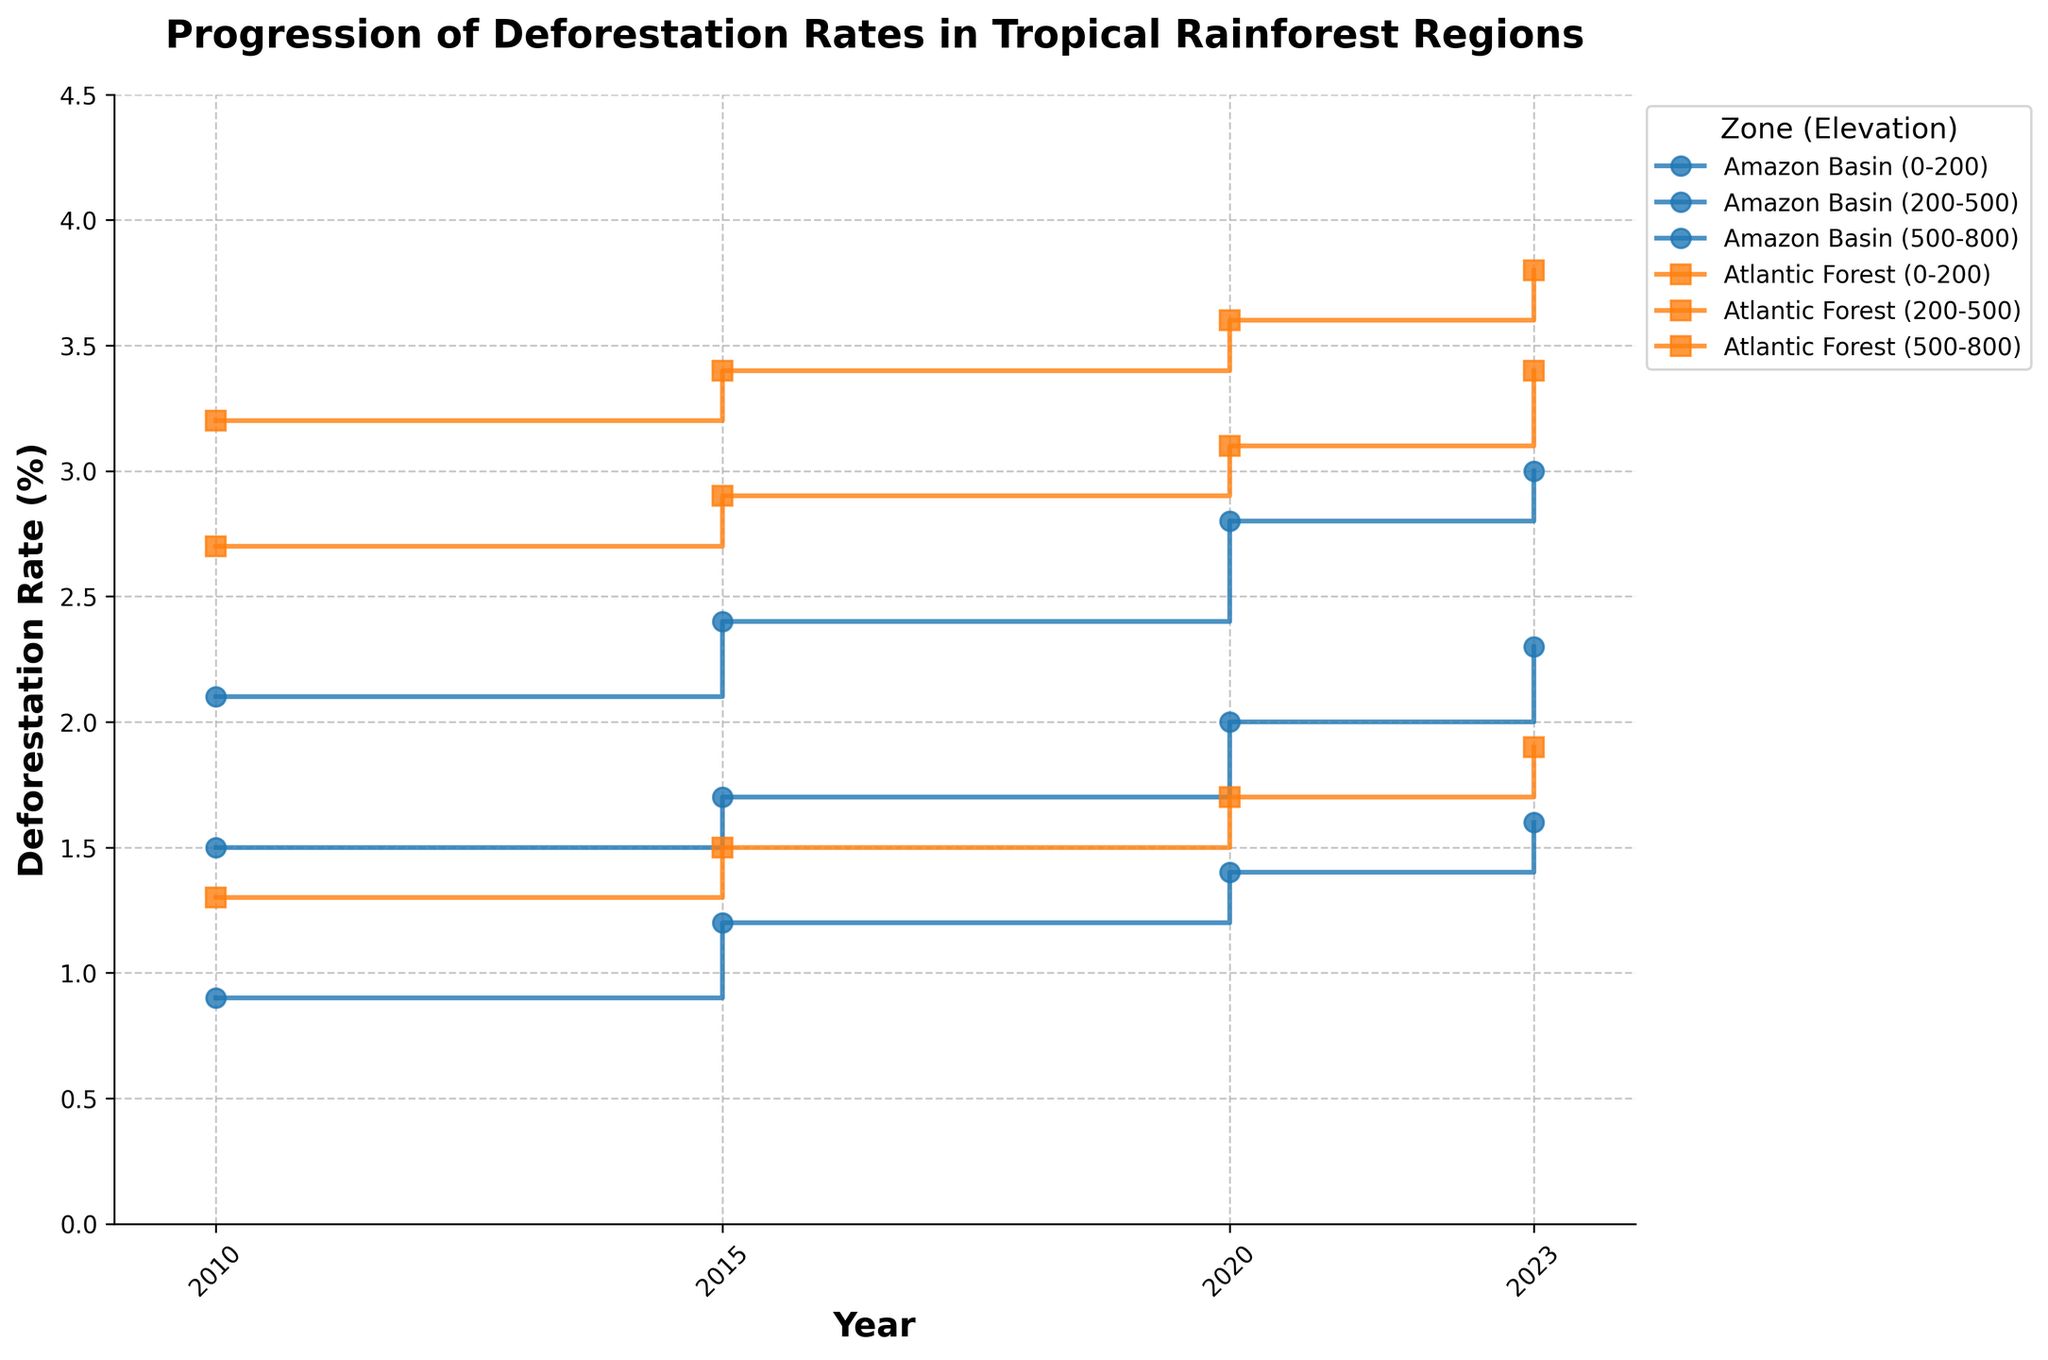What is the title of the plot? The title of the plot is prominently displayed at the top of the figure.
Answer: Progression of Deforestation Rates in Tropical Rainforest Regions What is the deforestation rate for the Amazon Basin at an elevation of 500-800 meters in 2015? Locate the data line for the Amazon Basin with the elevation of 500-800 meters and check the value aligned with the year 2015.
Answer: 1.2% How does the deforestation rate of the Atlantic Forest at 200-500 meters in 2020 compare to that in 2023? Identify the rates for the specified elevation in the Atlantic Forest for both years and compare them.
Answer: Higher in 2023 What is the difference in the deforestation rates for the Amazon Basin at 0-200 meters between 2010 and 2023? Note the deforestation rates for the Amazon Basin at 0-200 meters for the years 2010 and 2023 and subtract the 2010 value from the 2023 value.
Answer: 0.8% Which zone and elevation combination had the highest deforestation rate in 2010? Look at the deforestation rates for all zone and elevation combinations in 2010 and identify the highest value.
Answer: Atlantic Forest (0-200 meters) Did any zone show a constant increase in deforestation rates across all elevations from 2010 to 2023? Examine the step trends for all elevations within each zone from 2010 to 2023 to see if they consistently increase.
Answer: No What's the average deforestation rate for the Amazon Basin across all elevations in 2020? Add the deforestation rates of the Amazon Basin at all elevations for 2020 and divide by the number of elevations.
Answer: 2.07% Which elevation within the Atlantic Forest showed the smallest change in deforestation rates from 2010 to 2023? Calculate the change in deforestation rates for each elevation in the Atlantic Forest between 2010 and 2023 and identify the smallest change.
Answer: 500-800 meters Is there a year when the deforestation rate for both zones at 200-500 meters was equal? Compare the deforestation rates for the 200-500 meter elevation of both zones across all years to check for equality.
Answer: No Between 2010 to 2023, which zone had more consistent deforestation rates at 500-800 meters? Analyze the step plots for 500-800 meters in both zones and determine which one shows less fluctuation in rates.
Answer: Amazon Basin 